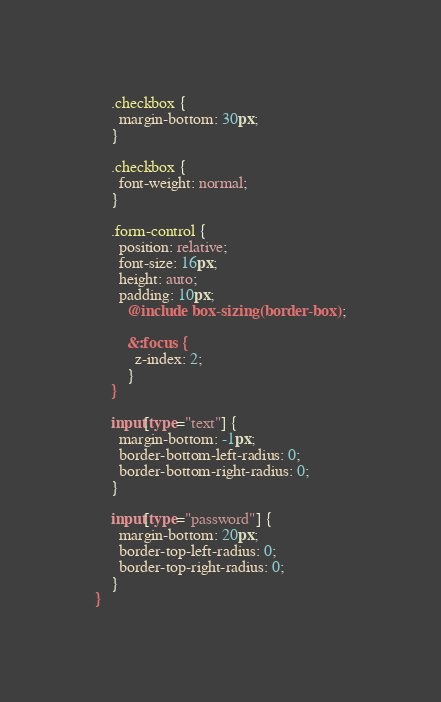<code> <loc_0><loc_0><loc_500><loc_500><_CSS_>    .checkbox {
      margin-bottom: 30px;
    }

    .checkbox {
      font-weight: normal;
    }

    .form-control {
      position: relative;
      font-size: 16px;
      height: auto;
      padding: 10px;
        @include box-sizing(border-box);

        &:focus {
          z-index: 2;
        }
    }

    input[type="text"] {
      margin-bottom: -1px;
      border-bottom-left-radius: 0;
      border-bottom-right-radius: 0;
    }

    input[type="password"] {
      margin-bottom: 20px;
      border-top-left-radius: 0;
      border-top-right-radius: 0;
    }
}
</code> 